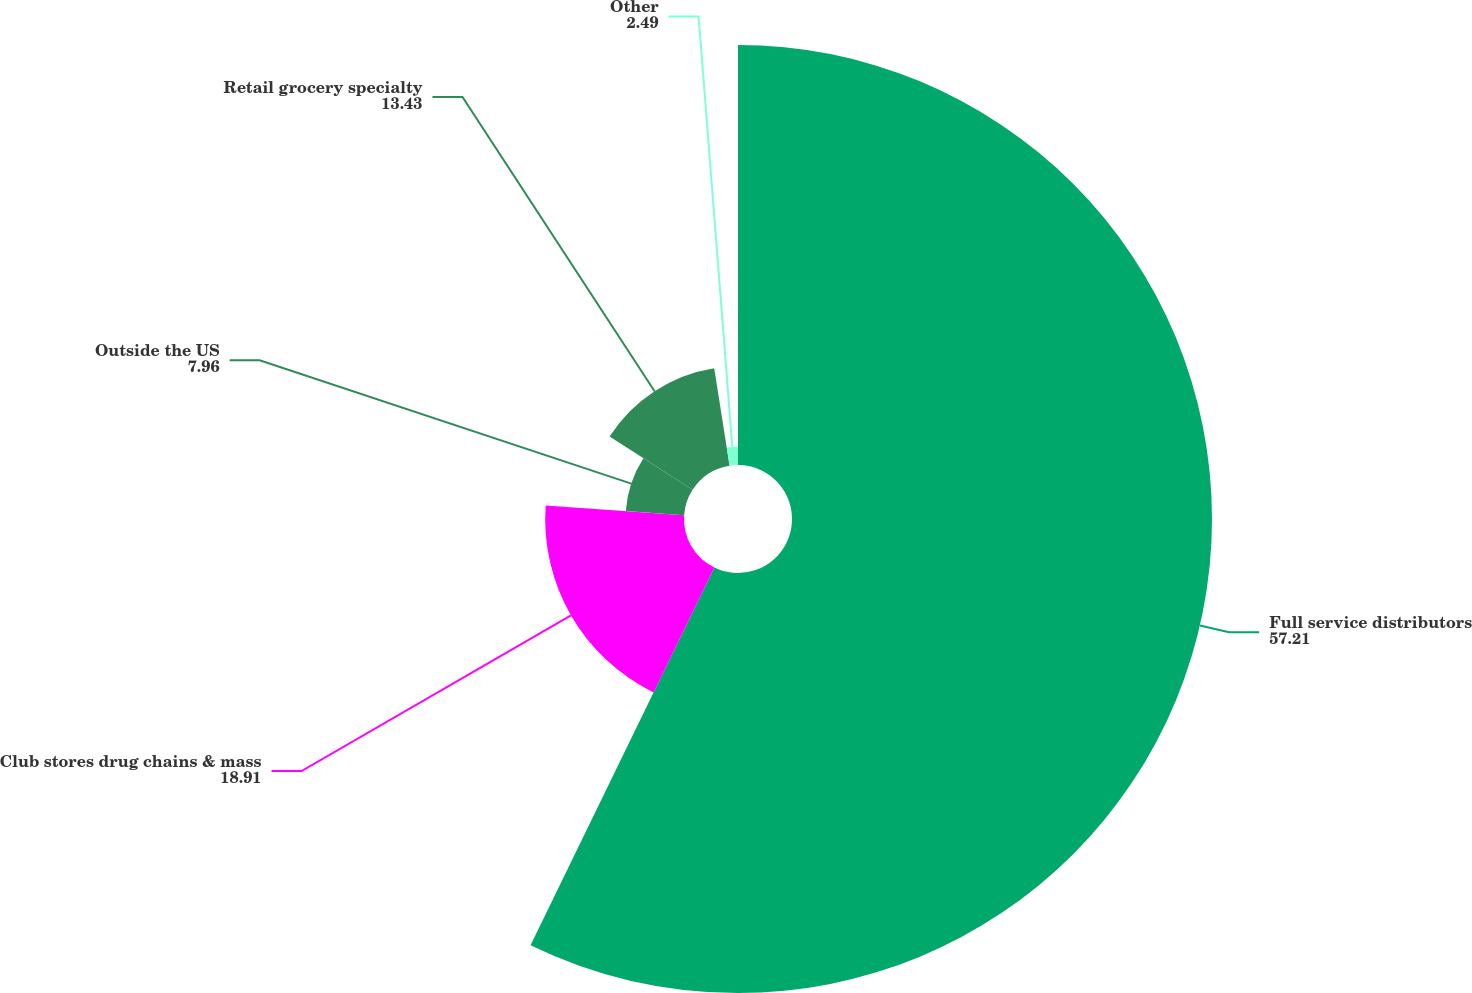<chart> <loc_0><loc_0><loc_500><loc_500><pie_chart><fcel>Full service distributors<fcel>Club stores drug chains & mass<fcel>Outside the US<fcel>Retail grocery specialty<fcel>Other<nl><fcel>57.21%<fcel>18.91%<fcel>7.96%<fcel>13.43%<fcel>2.49%<nl></chart> 